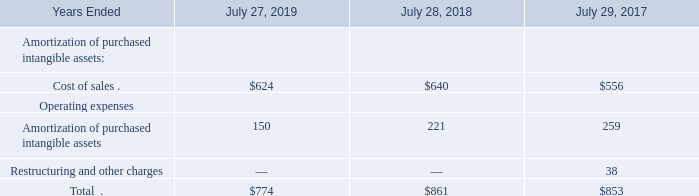5. Goodwill and Purchased Intangible Assets
(b) Purchased Intangible Assets
The following table presents the amortization of purchased intangible assets (in millions):
Which years does the table provide information for the amortization of purchased intangible assets? 2019, 2018, 2017. What were the cost of sales in 2019?
Answer scale should be: million. 624. What was the total amortization of purchased intangible assets in 2018?
Answer scale should be: million. 861. What was the change in cost of sales between 2017 and 2018?
Answer scale should be: million. 640-556
Answer: 84. How many years did Amortization of purchased intangible assets exceed $200 million? 2018##2017
Answer: 2. What was the percentage change in total amortization of purchased intangible assets between 2018 and 2019?
Answer scale should be: percent. (774-861)/861
Answer: -10.1. 